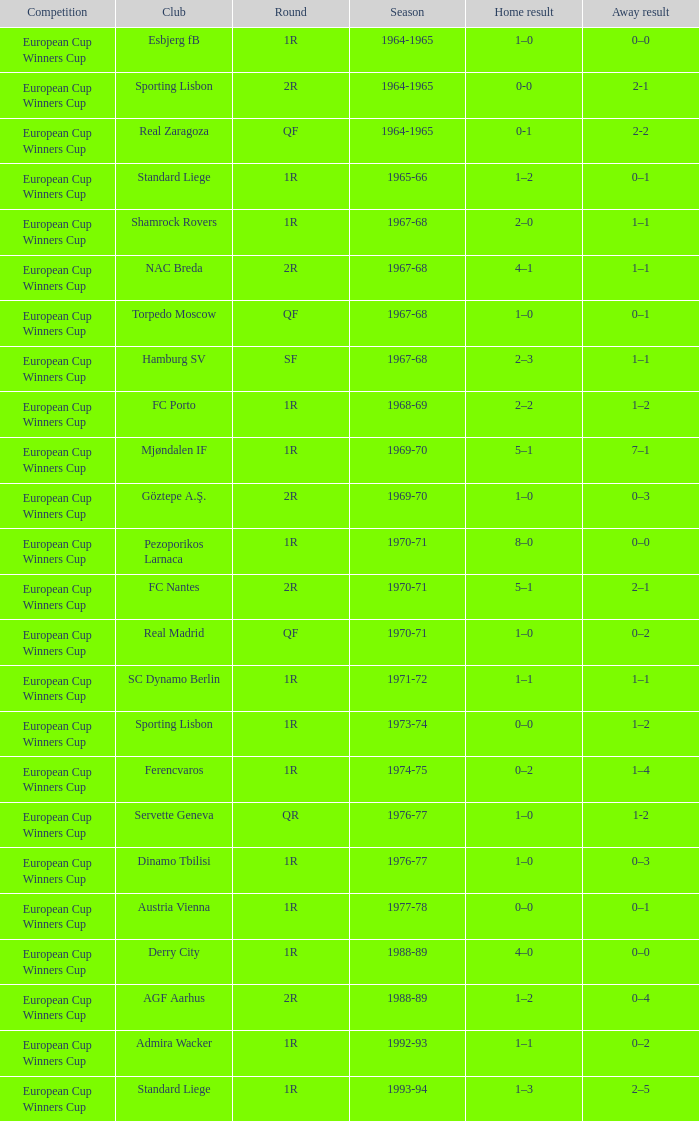Round of 1r, and an away result of 7–1 is what season? 1969-70. 